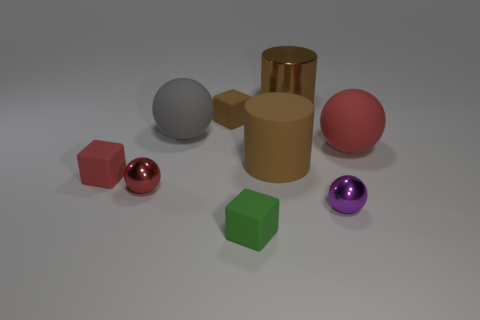What is the material of the other big cylinder that is the same color as the rubber cylinder?
Keep it short and to the point. Metal. There is a large metallic thing; is it the same color as the big cylinder that is on the left side of the big metal thing?
Give a very brief answer. Yes. What number of other things are there of the same color as the metallic cylinder?
Provide a succinct answer. 2. Are there more brown rubber objects that are on the left side of the small green thing than small brown things in front of the purple thing?
Your answer should be very brief. Yes. There is a gray matte ball; are there any matte cubes behind it?
Give a very brief answer. Yes. What material is the ball that is in front of the red cube and behind the small purple ball?
Your answer should be very brief. Metal. There is another shiny object that is the same shape as the small red shiny thing; what color is it?
Ensure brevity in your answer.  Purple. There is a red sphere right of the tiny green thing; are there any tiny red matte blocks behind it?
Ensure brevity in your answer.  No. What size is the green matte thing?
Give a very brief answer. Small. What is the shape of the rubber thing that is in front of the large red ball and on the left side of the tiny green cube?
Your response must be concise. Cube. 